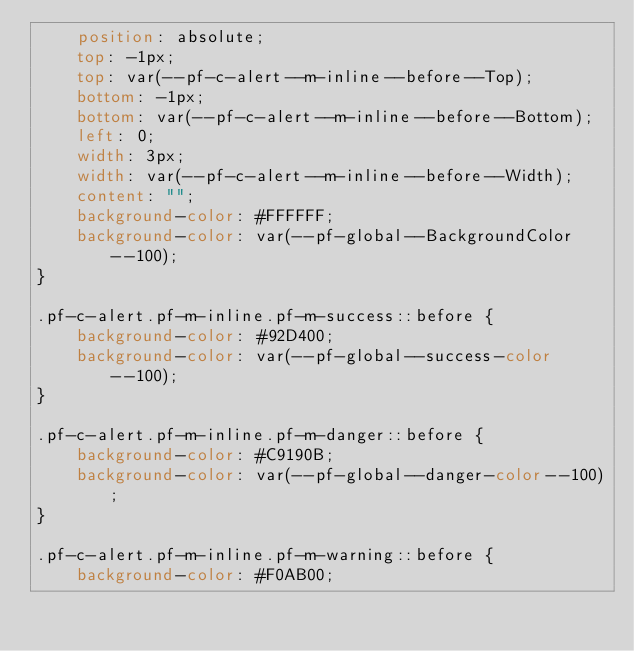Convert code to text. <code><loc_0><loc_0><loc_500><loc_500><_CSS_>    position: absolute;
    top: -1px;
    top: var(--pf-c-alert--m-inline--before--Top);
    bottom: -1px;
    bottom: var(--pf-c-alert--m-inline--before--Bottom);
    left: 0;
    width: 3px;
    width: var(--pf-c-alert--m-inline--before--Width);
    content: "";
    background-color: #FFFFFF;
    background-color: var(--pf-global--BackgroundColor--100);
}

.pf-c-alert.pf-m-inline.pf-m-success::before {
    background-color: #92D400;
    background-color: var(--pf-global--success-color--100);
}

.pf-c-alert.pf-m-inline.pf-m-danger::before {
    background-color: #C9190B;
    background-color: var(--pf-global--danger-color--100);
}

.pf-c-alert.pf-m-inline.pf-m-warning::before {
    background-color: #F0AB00;</code> 